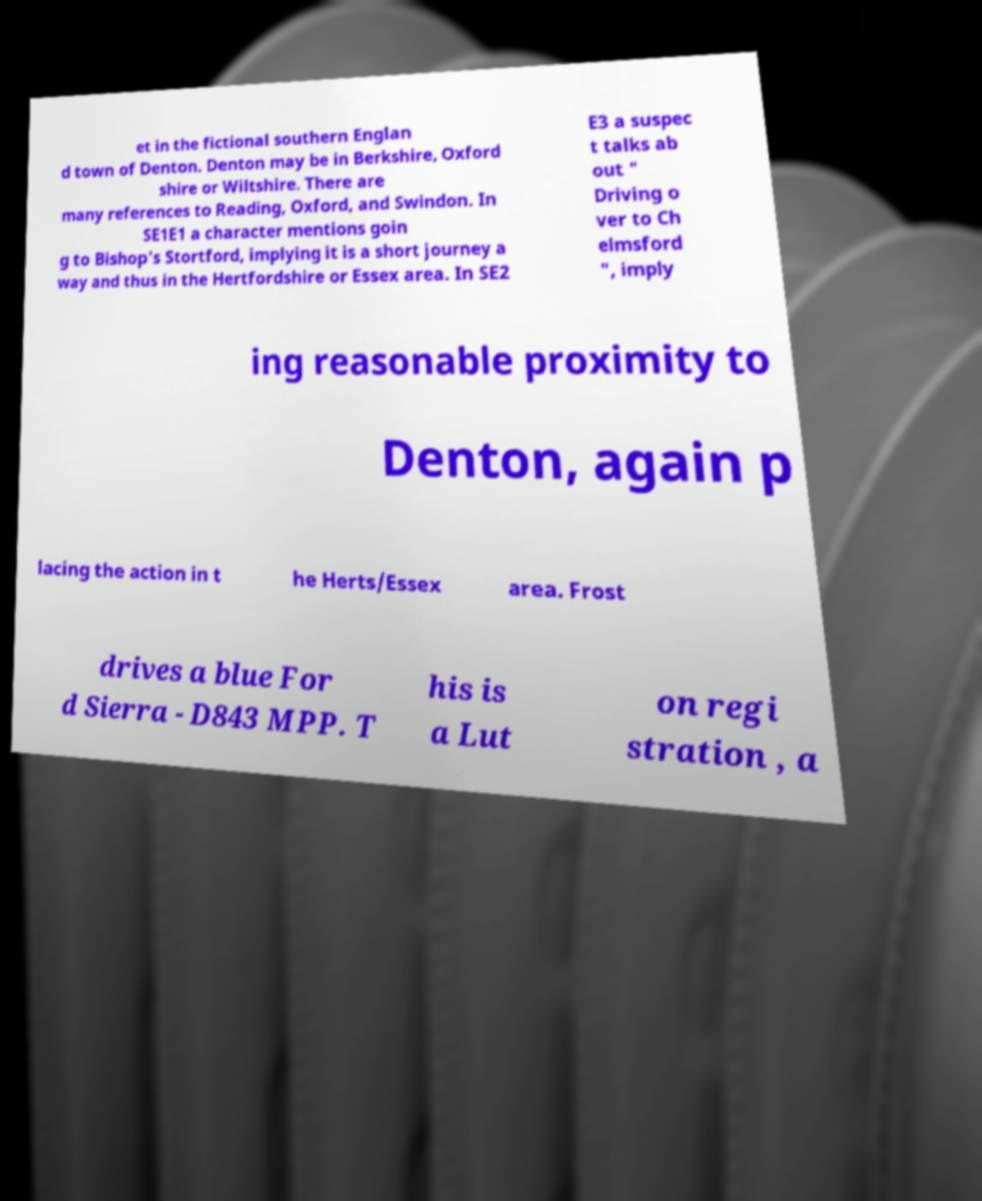Please identify and transcribe the text found in this image. et in the fictional southern Englan d town of Denton. Denton may be in Berkshire, Oxford shire or Wiltshire. There are many references to Reading, Oxford, and Swindon. In SE1E1 a character mentions goin g to Bishop's Stortford, implying it is a short journey a way and thus in the Hertfordshire or Essex area. In SE2 E3 a suspec t talks ab out " Driving o ver to Ch elmsford ", imply ing reasonable proximity to Denton, again p lacing the action in t he Herts/Essex area. Frost drives a blue For d Sierra - D843 MPP. T his is a Lut on regi stration , a 